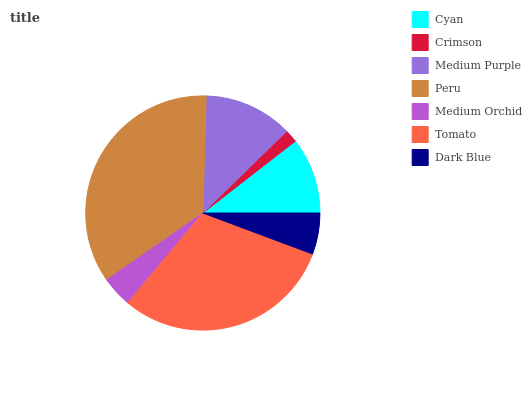Is Crimson the minimum?
Answer yes or no. Yes. Is Peru the maximum?
Answer yes or no. Yes. Is Medium Purple the minimum?
Answer yes or no. No. Is Medium Purple the maximum?
Answer yes or no. No. Is Medium Purple greater than Crimson?
Answer yes or no. Yes. Is Crimson less than Medium Purple?
Answer yes or no. Yes. Is Crimson greater than Medium Purple?
Answer yes or no. No. Is Medium Purple less than Crimson?
Answer yes or no. No. Is Cyan the high median?
Answer yes or no. Yes. Is Cyan the low median?
Answer yes or no. Yes. Is Medium Purple the high median?
Answer yes or no. No. Is Peru the low median?
Answer yes or no. No. 